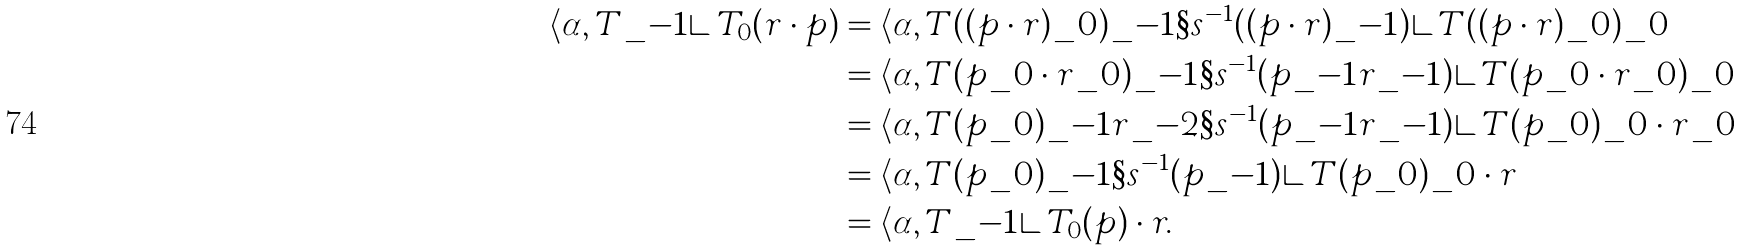<formula> <loc_0><loc_0><loc_500><loc_500>\langle \alpha , T \_ { - 1 } \rangle \, T _ { 0 } ( r \cdot p ) & = \langle \alpha , T ( ( p \cdot r ) \_ 0 ) \_ { - 1 } \S s ^ { - 1 } ( ( p \cdot r ) \_ { - 1 } ) \rangle \, T ( ( p \cdot r ) \_ 0 ) \_ 0 \\ & = \langle \alpha , T ( p \_ 0 \cdot r \_ 0 ) \_ { - 1 } \S s ^ { - 1 } ( p \_ { - 1 } r \_ { - 1 } ) \rangle \, T ( p \_ 0 \cdot r \_ 0 ) \_ 0 \\ & = \langle \alpha , T ( p \_ 0 ) \_ { - 1 } r \_ { - 2 } \S s ^ { - 1 } ( p \_ { - 1 } r \_ { - 1 } ) \rangle \, T ( p \_ 0 ) \_ 0 \cdot r \_ 0 \\ & = \langle \alpha , T ( p \_ 0 ) \_ { - 1 } \S s ^ { - 1 } ( p \_ { - 1 } ) \rangle \, T ( p \_ 0 ) \_ 0 \cdot r \\ & = \langle \alpha , T \_ { - 1 } \rangle \, T _ { 0 } ( p ) \cdot r .</formula> 